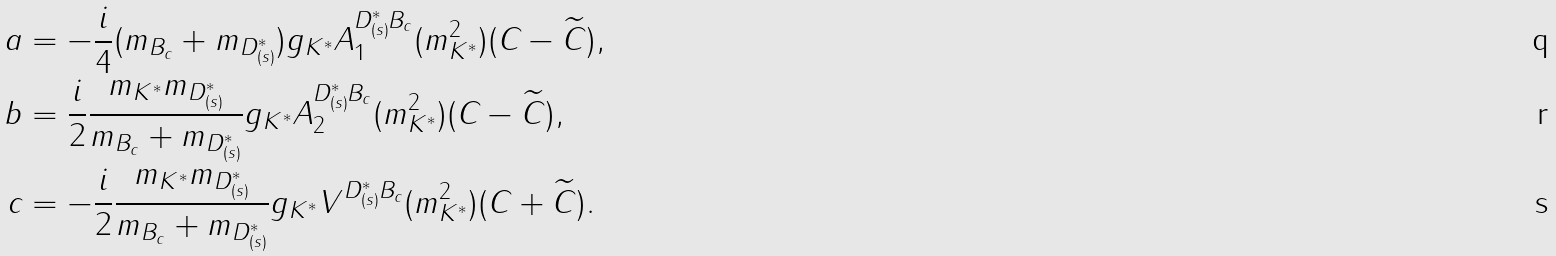<formula> <loc_0><loc_0><loc_500><loc_500>a & = - \frac { i } { 4 } ( m _ { B _ { c } } + m _ { D _ { ( s ) } ^ { * } } ) g _ { K ^ { * } } A _ { 1 } ^ { { D _ { ( s ) } ^ { * } } { B _ { c } } } ( m _ { K ^ { * } } ^ { 2 } ) ( C - \widetilde { C } ) , \\ b & = \frac { i } { 2 } \frac { m _ { K ^ { * } } m _ { D _ { ( s ) } ^ { * } } } { m _ { B _ { c } } + m _ { D _ { ( s ) } ^ { * } } } g _ { K ^ { * } } A _ { 2 } ^ { { D _ { ( s ) } ^ { * } } { B _ { c } } } ( m _ { K ^ { * } } ^ { 2 } ) ( C - \widetilde { C } ) , \\ c & = - \frac { i } { 2 } \frac { m _ { K ^ { * } } m _ { D _ { ( s ) } ^ { * } } } { m _ { B _ { c } } + m _ { D _ { ( s ) } ^ { * } } } g _ { K ^ { * } } V ^ { { D _ { ( s ) } ^ { * } } { B _ { c } } } ( m _ { K ^ { * } } ^ { 2 } ) ( C + \widetilde { C } ) .</formula> 